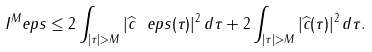Convert formula to latex. <formula><loc_0><loc_0><loc_500><loc_500>I ^ { M } _ { \ } e p s \leq 2 \int _ { | \tau | > M } | \widehat { c } _ { \ } e p s ( \tau ) | ^ { 2 } \, d \tau + 2 \int _ { | \tau | > M } | \widehat { c } ( \tau ) | ^ { 2 } \, d \tau .</formula> 